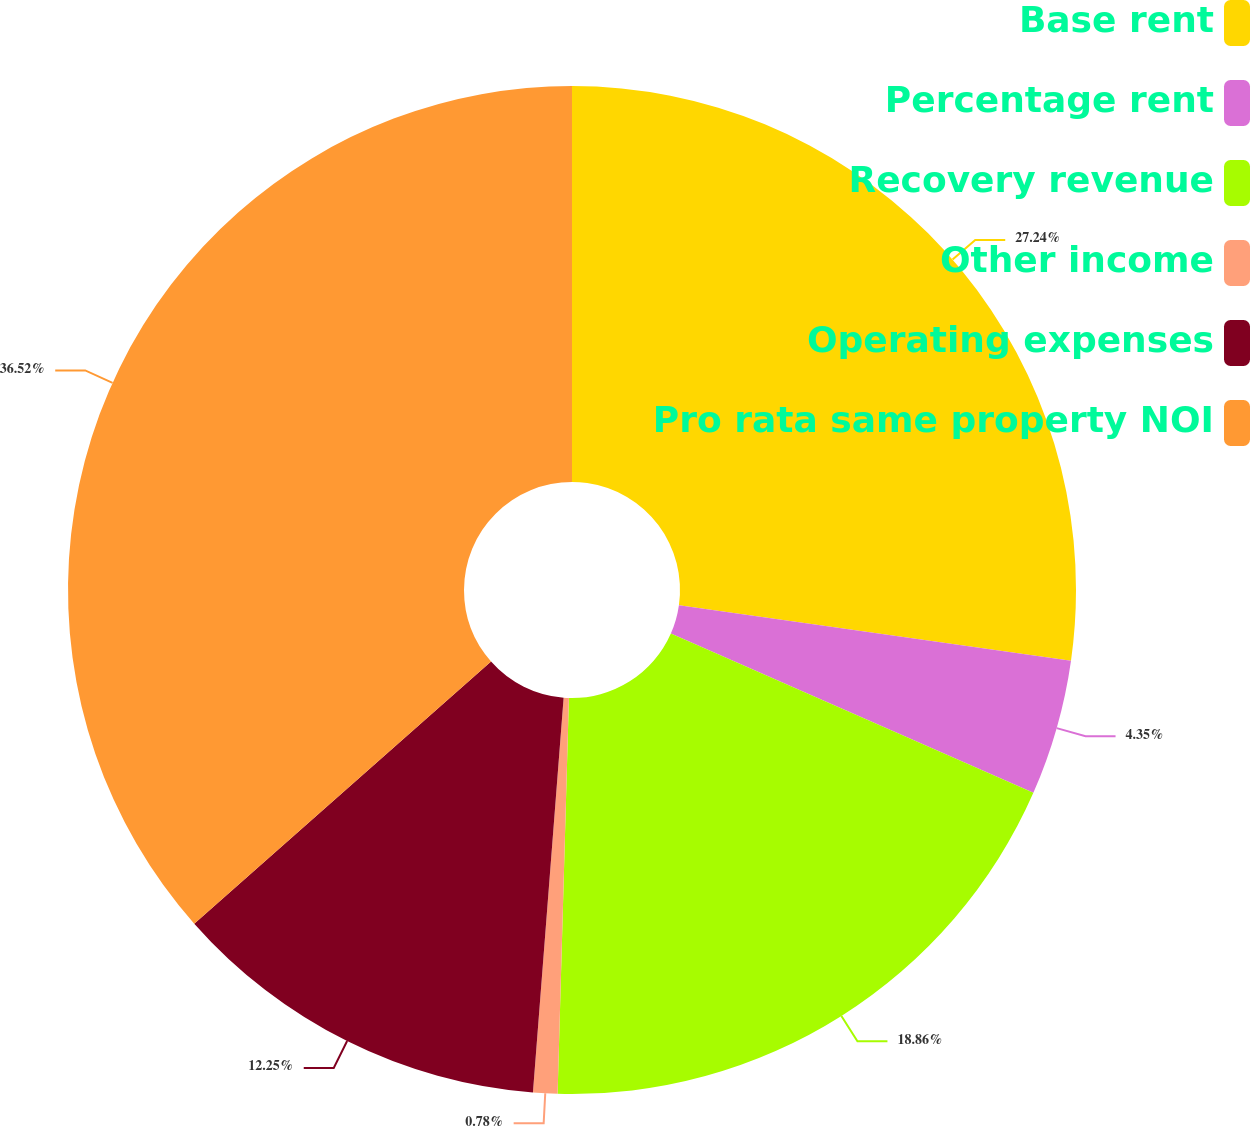Convert chart to OTSL. <chart><loc_0><loc_0><loc_500><loc_500><pie_chart><fcel>Base rent<fcel>Percentage rent<fcel>Recovery revenue<fcel>Other income<fcel>Operating expenses<fcel>Pro rata same property NOI<nl><fcel>27.24%<fcel>4.35%<fcel>18.86%<fcel>0.78%<fcel>12.25%<fcel>36.51%<nl></chart> 